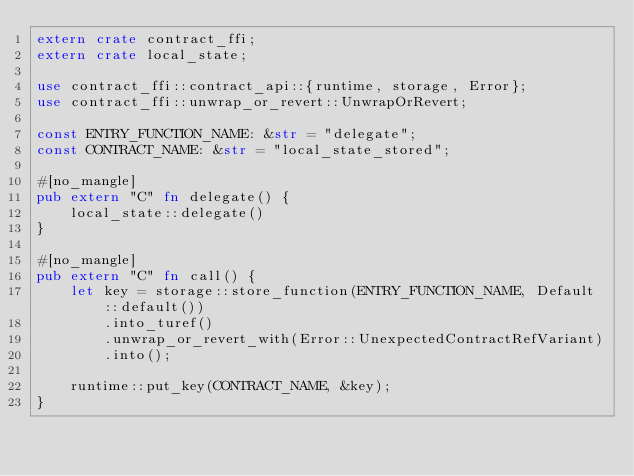Convert code to text. <code><loc_0><loc_0><loc_500><loc_500><_Rust_>extern crate contract_ffi;
extern crate local_state;

use contract_ffi::contract_api::{runtime, storage, Error};
use contract_ffi::unwrap_or_revert::UnwrapOrRevert;

const ENTRY_FUNCTION_NAME: &str = "delegate";
const CONTRACT_NAME: &str = "local_state_stored";

#[no_mangle]
pub extern "C" fn delegate() {
    local_state::delegate()
}

#[no_mangle]
pub extern "C" fn call() {
    let key = storage::store_function(ENTRY_FUNCTION_NAME, Default::default())
        .into_turef()
        .unwrap_or_revert_with(Error::UnexpectedContractRefVariant)
        .into();

    runtime::put_key(CONTRACT_NAME, &key);
}
</code> 